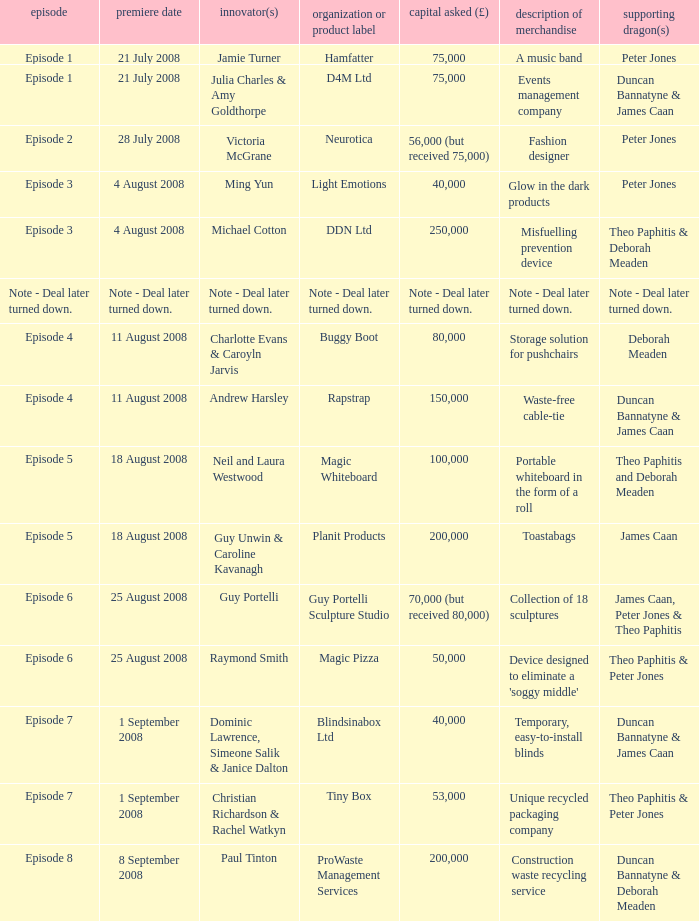When did episode 6 first air with entrepreneur Guy Portelli? 25 August 2008. 